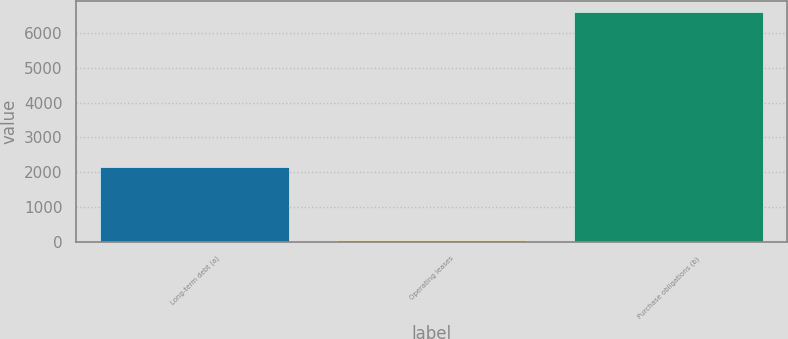Convert chart to OTSL. <chart><loc_0><loc_0><loc_500><loc_500><bar_chart><fcel>Long-term debt (a)<fcel>Operating leases<fcel>Purchase obligations (b)<nl><fcel>2148<fcel>49<fcel>6593<nl></chart> 